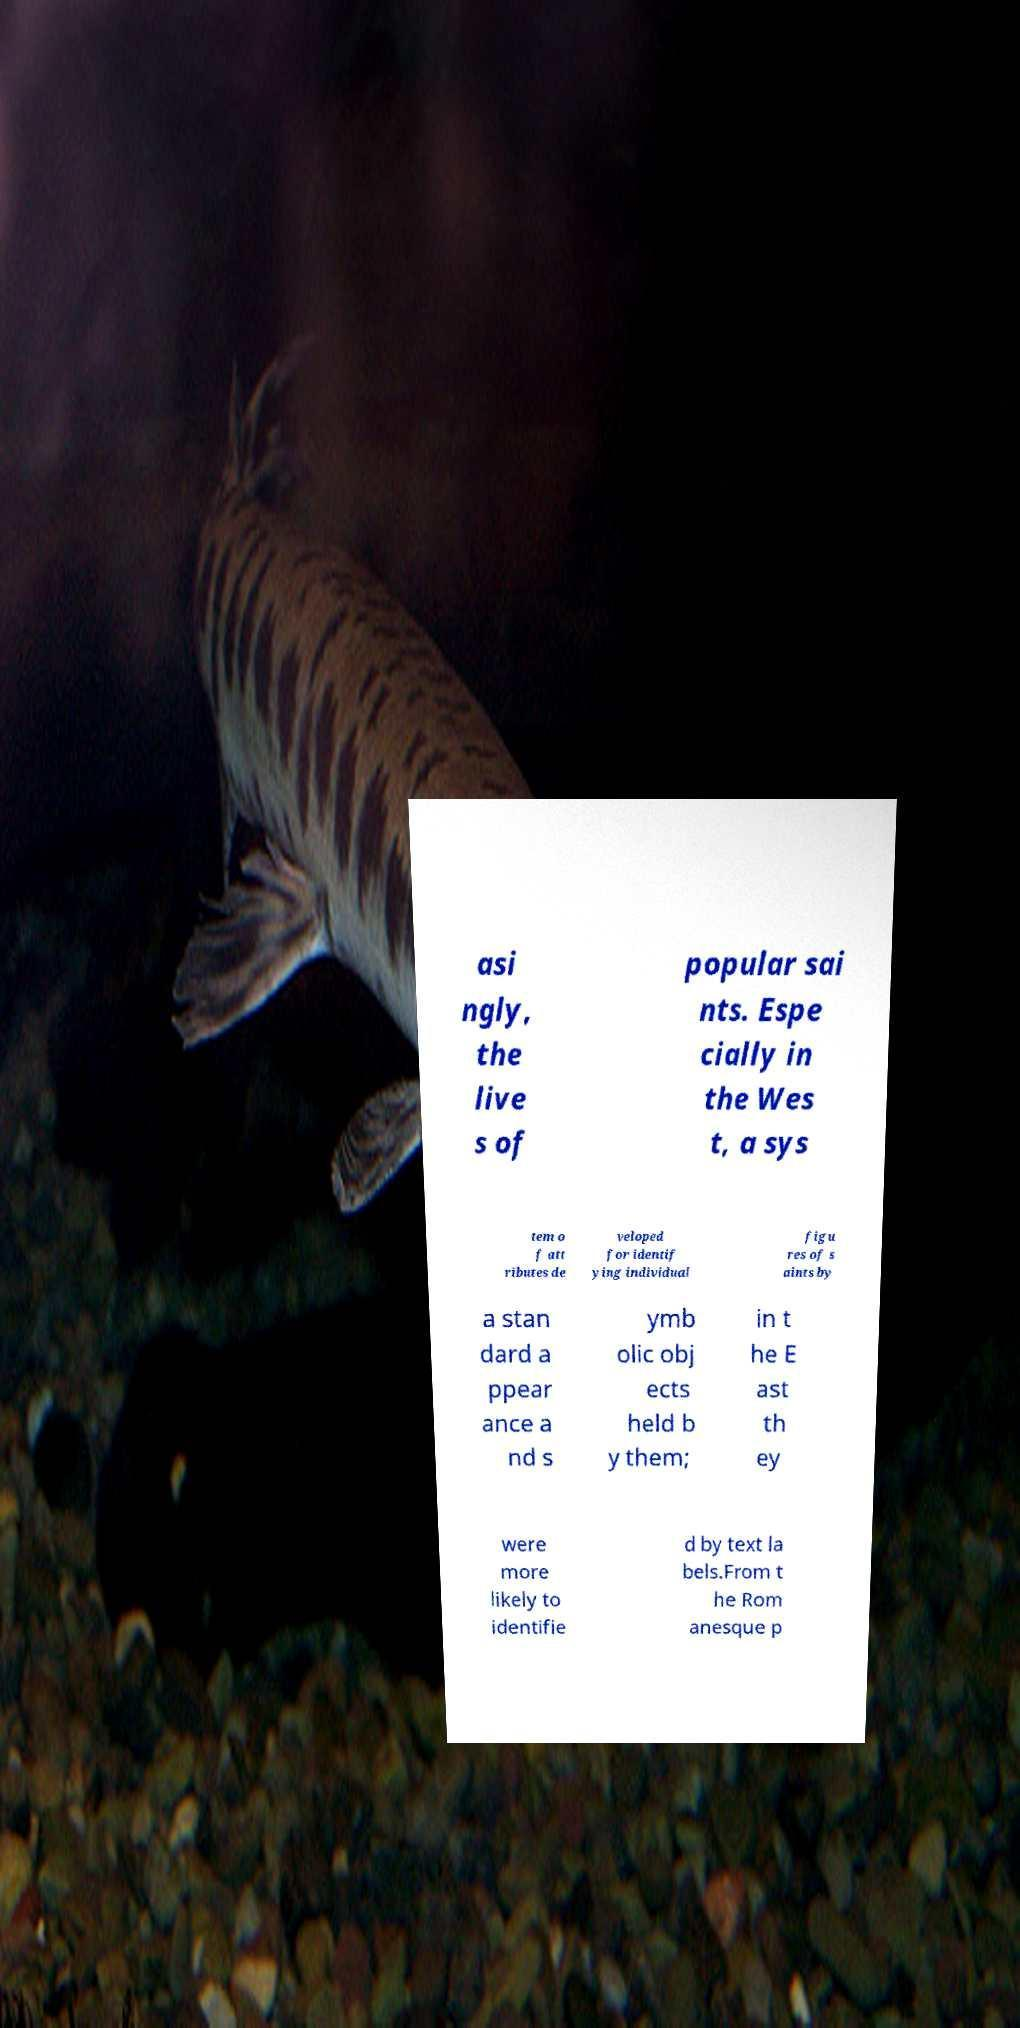What messages or text are displayed in this image? I need them in a readable, typed format. asi ngly, the live s of popular sai nts. Espe cially in the Wes t, a sys tem o f att ributes de veloped for identif ying individual figu res of s aints by a stan dard a ppear ance a nd s ymb olic obj ects held b y them; in t he E ast th ey were more likely to identifie d by text la bels.From t he Rom anesque p 